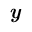<formula> <loc_0><loc_0><loc_500><loc_500>y</formula> 